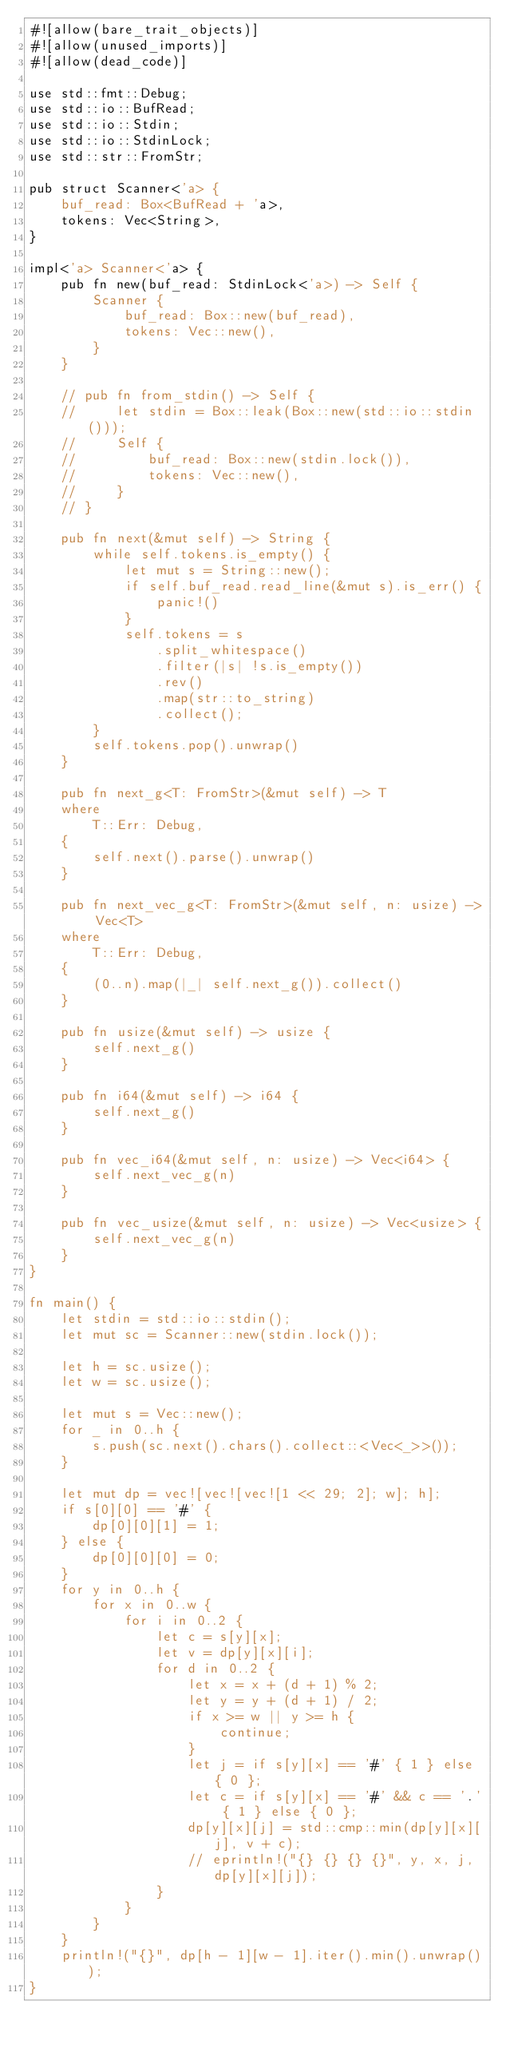Convert code to text. <code><loc_0><loc_0><loc_500><loc_500><_Rust_>#![allow(bare_trait_objects)]
#![allow(unused_imports)]
#![allow(dead_code)]

use std::fmt::Debug;
use std::io::BufRead;
use std::io::Stdin;
use std::io::StdinLock;
use std::str::FromStr;

pub struct Scanner<'a> {
    buf_read: Box<BufRead + 'a>,
    tokens: Vec<String>,
}

impl<'a> Scanner<'a> {
    pub fn new(buf_read: StdinLock<'a>) -> Self {
        Scanner {
            buf_read: Box::new(buf_read),
            tokens: Vec::new(),
        }
    }

    // pub fn from_stdin() -> Self {
    //     let stdin = Box::leak(Box::new(std::io::stdin()));
    //     Self {
    //         buf_read: Box::new(stdin.lock()),
    //         tokens: Vec::new(),
    //     }
    // }

    pub fn next(&mut self) -> String {
        while self.tokens.is_empty() {
            let mut s = String::new();
            if self.buf_read.read_line(&mut s).is_err() {
                panic!()
            }
            self.tokens = s
                .split_whitespace()
                .filter(|s| !s.is_empty())
                .rev()
                .map(str::to_string)
                .collect();
        }
        self.tokens.pop().unwrap()
    }

    pub fn next_g<T: FromStr>(&mut self) -> T
    where
        T::Err: Debug,
    {
        self.next().parse().unwrap()
    }

    pub fn next_vec_g<T: FromStr>(&mut self, n: usize) -> Vec<T>
    where
        T::Err: Debug,
    {
        (0..n).map(|_| self.next_g()).collect()
    }

    pub fn usize(&mut self) -> usize {
        self.next_g()
    }

    pub fn i64(&mut self) -> i64 {
        self.next_g()
    }

    pub fn vec_i64(&mut self, n: usize) -> Vec<i64> {
        self.next_vec_g(n)
    }

    pub fn vec_usize(&mut self, n: usize) -> Vec<usize> {
        self.next_vec_g(n)
    }
}

fn main() {
    let stdin = std::io::stdin();
    let mut sc = Scanner::new(stdin.lock());

    let h = sc.usize();
    let w = sc.usize();

    let mut s = Vec::new();
    for _ in 0..h {
        s.push(sc.next().chars().collect::<Vec<_>>());
    }

    let mut dp = vec![vec![vec![1 << 29; 2]; w]; h];
    if s[0][0] == '#' {
        dp[0][0][1] = 1;
    } else {
        dp[0][0][0] = 0;
    }
    for y in 0..h {
        for x in 0..w {
            for i in 0..2 {
                let c = s[y][x];
                let v = dp[y][x][i];
                for d in 0..2 {
                    let x = x + (d + 1) % 2;
                    let y = y + (d + 1) / 2;
                    if x >= w || y >= h {
                        continue;
                    }
                    let j = if s[y][x] == '#' { 1 } else { 0 };
                    let c = if s[y][x] == '#' && c == '.' { 1 } else { 0 };
                    dp[y][x][j] = std::cmp::min(dp[y][x][j], v + c);
                    // eprintln!("{} {} {} {}", y, x, j, dp[y][x][j]);
                }
            }
        }
    }
    println!("{}", dp[h - 1][w - 1].iter().min().unwrap());
}
</code> 